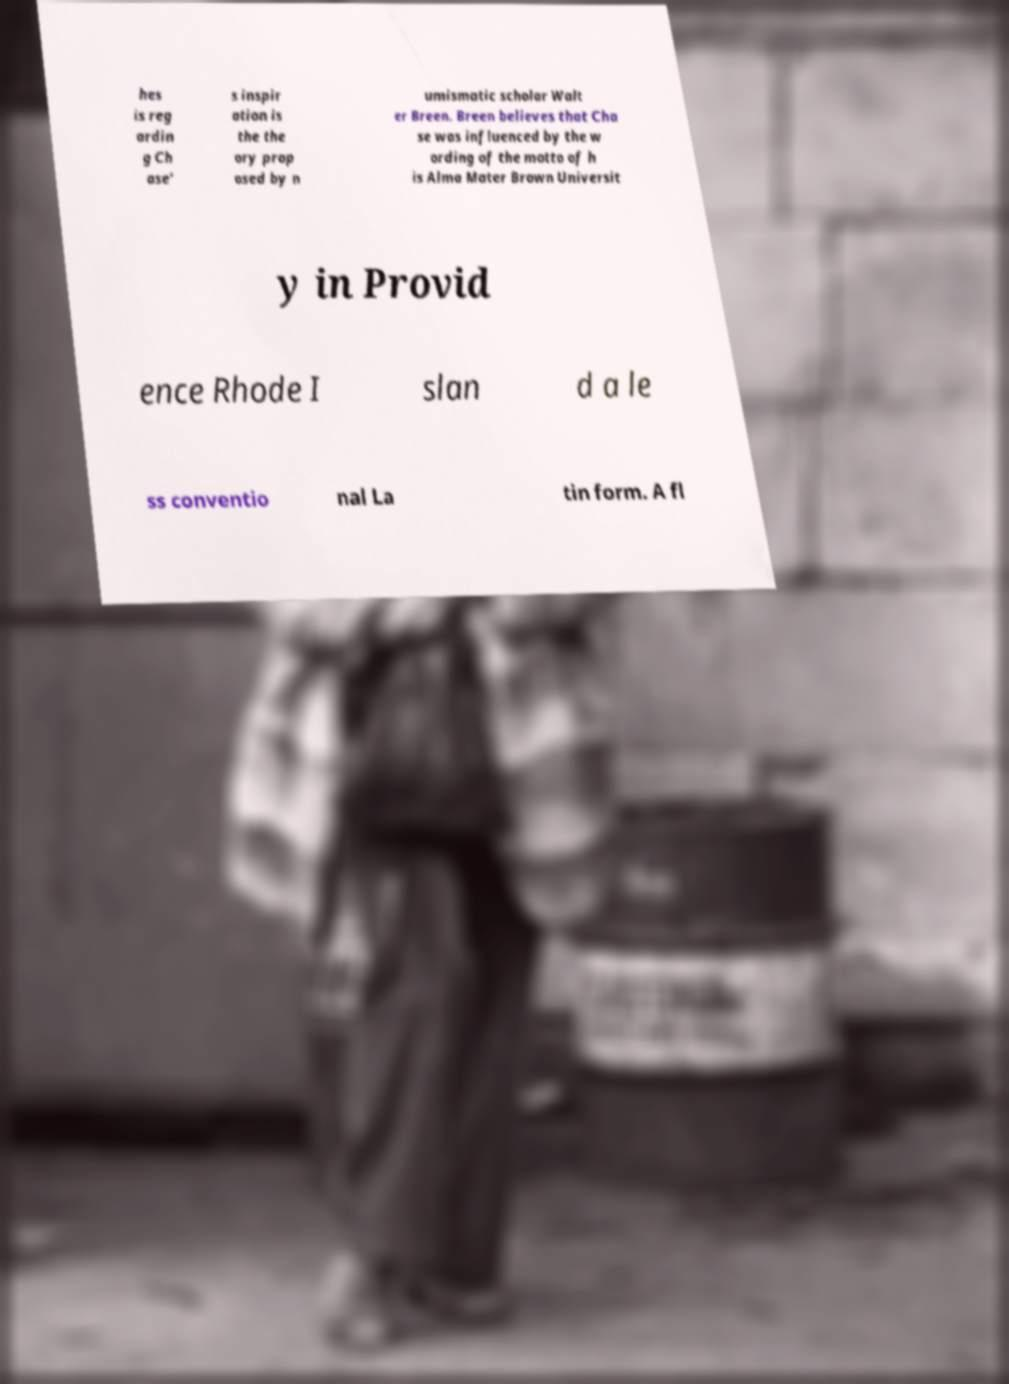Can you accurately transcribe the text from the provided image for me? hes is reg ardin g Ch ase’ s inspir ation is the the ory prop osed by n umismatic scholar Walt er Breen. Breen believes that Cha se was influenced by the w ording of the motto of h is Alma Mater Brown Universit y in Provid ence Rhode I slan d a le ss conventio nal La tin form. A fl 